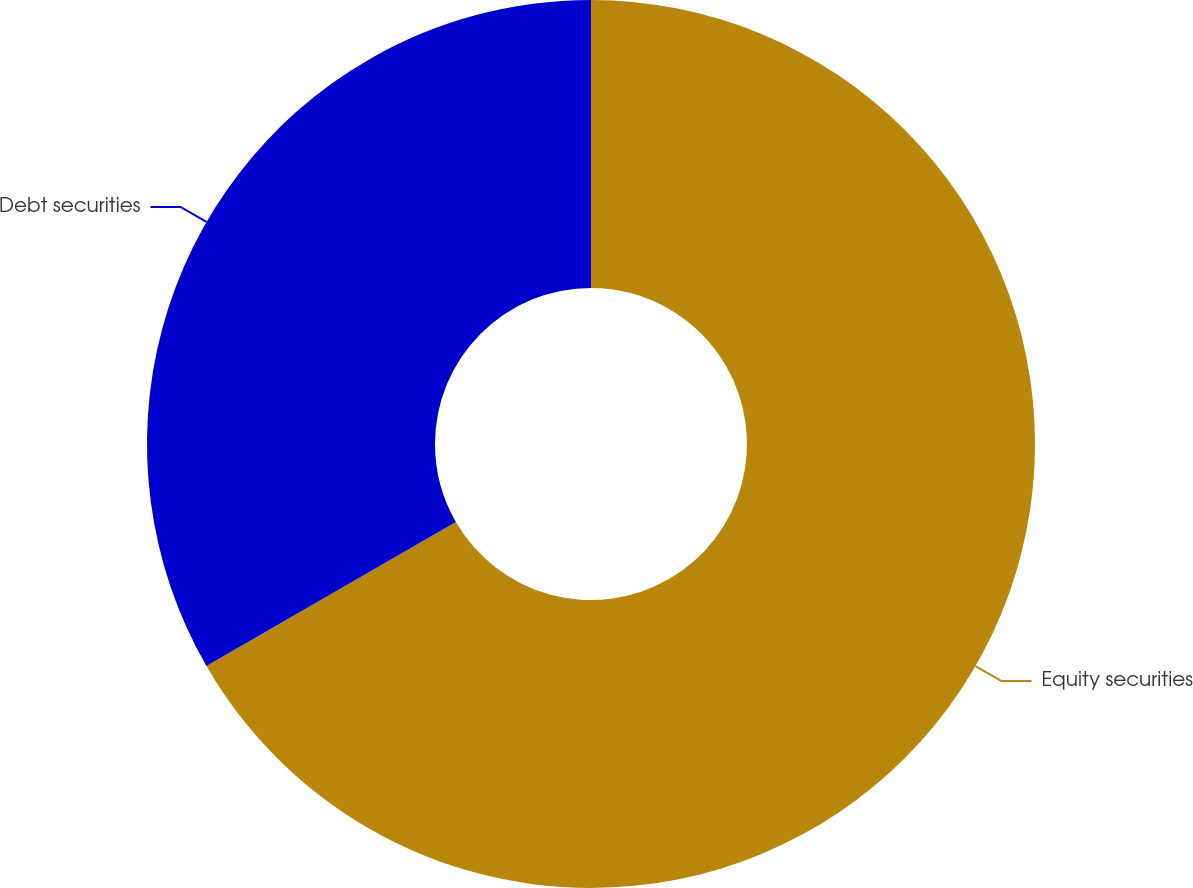Convert chart. <chart><loc_0><loc_0><loc_500><loc_500><pie_chart><fcel>Equity securities<fcel>Debt securities<nl><fcel>66.67%<fcel>33.33%<nl></chart> 